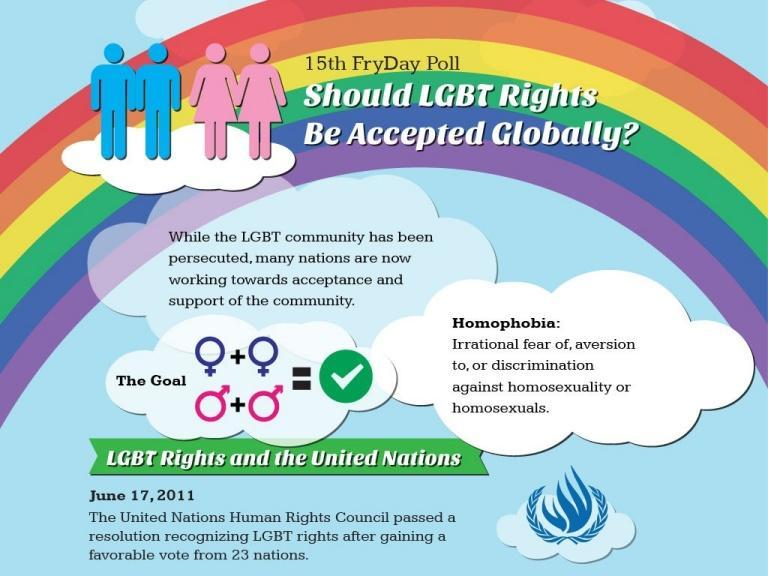in which colour are the females represented, blue or pink
Answer the question with a short phrase. pink in which colour are the males represented, blue or pink blue 